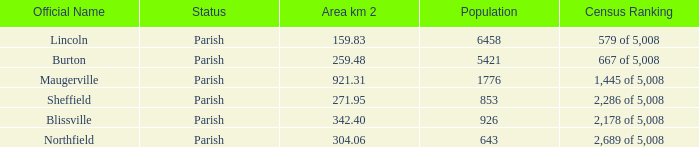What are the official name(s) of places with an area of 304.06 km2? Northfield. 